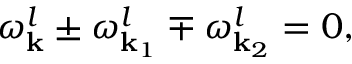<formula> <loc_0><loc_0><loc_500><loc_500>\omega _ { k } ^ { l } \pm \omega _ { { k } _ { 1 } } ^ { l } \mp \omega _ { { k } _ { 2 } } ^ { l } = 0 ,</formula> 